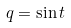Convert formula to latex. <formula><loc_0><loc_0><loc_500><loc_500>q = \sin t</formula> 